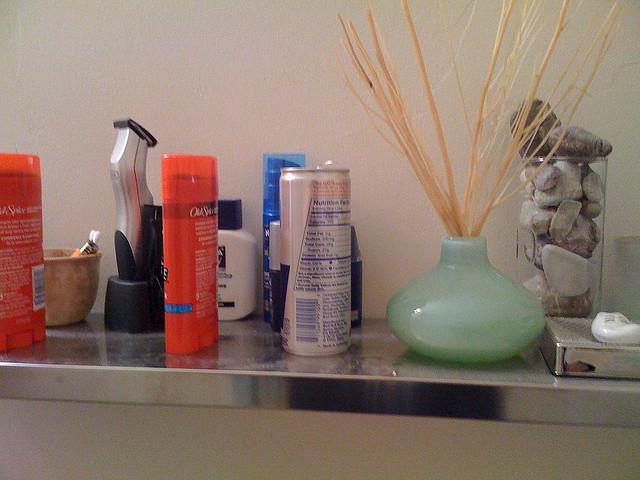What is the brand on the bottle?
Write a very short answer. Old spice. Is the bottle taller than the vase?
Give a very brief answer. Yes. What kind of deodorant is that?
Quick response, please. Old spice. What type of drink is that?
Answer briefly. Red bull. Are there antique items here?
Be succinct. No. How many deodorants are on the shelf?
Short answer required. 2. What is in front of the vase?
Answer briefly. Can. Do you see a cheese grater?
Write a very short answer. No. How many more toothbrushes could fit in the stand?
Give a very brief answer. 0. What color is the bottle?
Answer briefly. Green. Is there any tissues in the picture?
Give a very brief answer. No. 